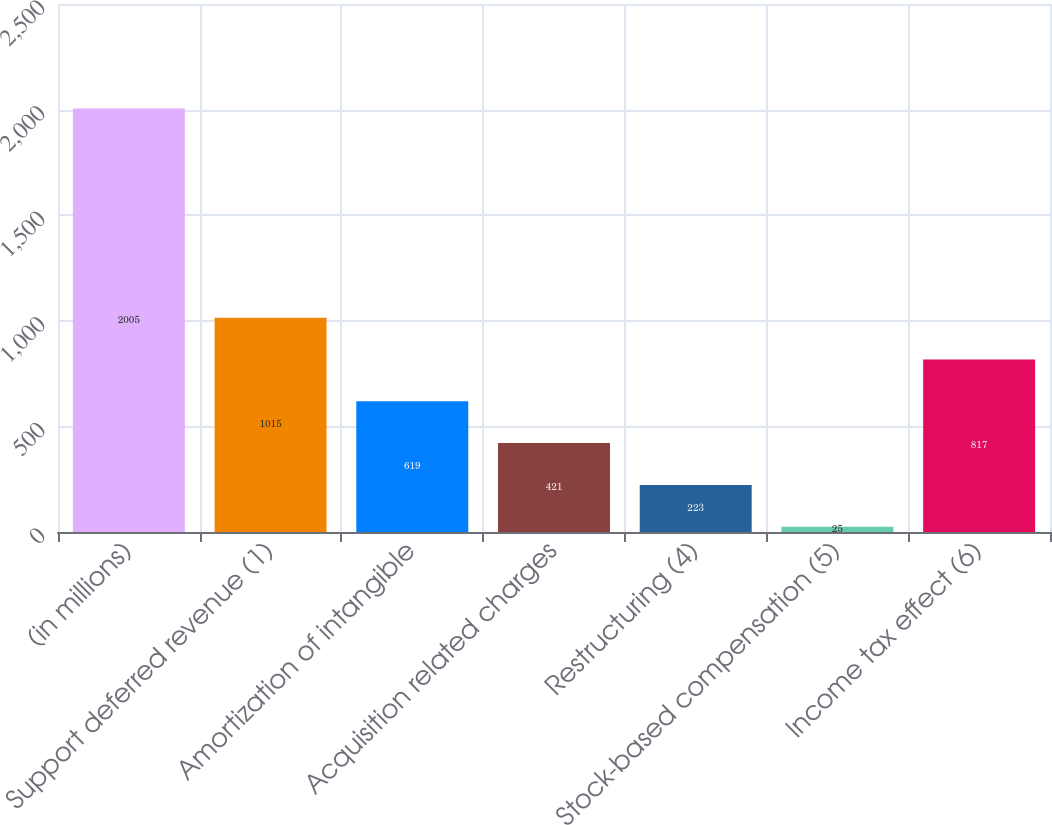<chart> <loc_0><loc_0><loc_500><loc_500><bar_chart><fcel>(in millions)<fcel>Support deferred revenue (1)<fcel>Amortization of intangible<fcel>Acquisition related charges<fcel>Restructuring (4)<fcel>Stock-based compensation (5)<fcel>Income tax effect (6)<nl><fcel>2005<fcel>1015<fcel>619<fcel>421<fcel>223<fcel>25<fcel>817<nl></chart> 